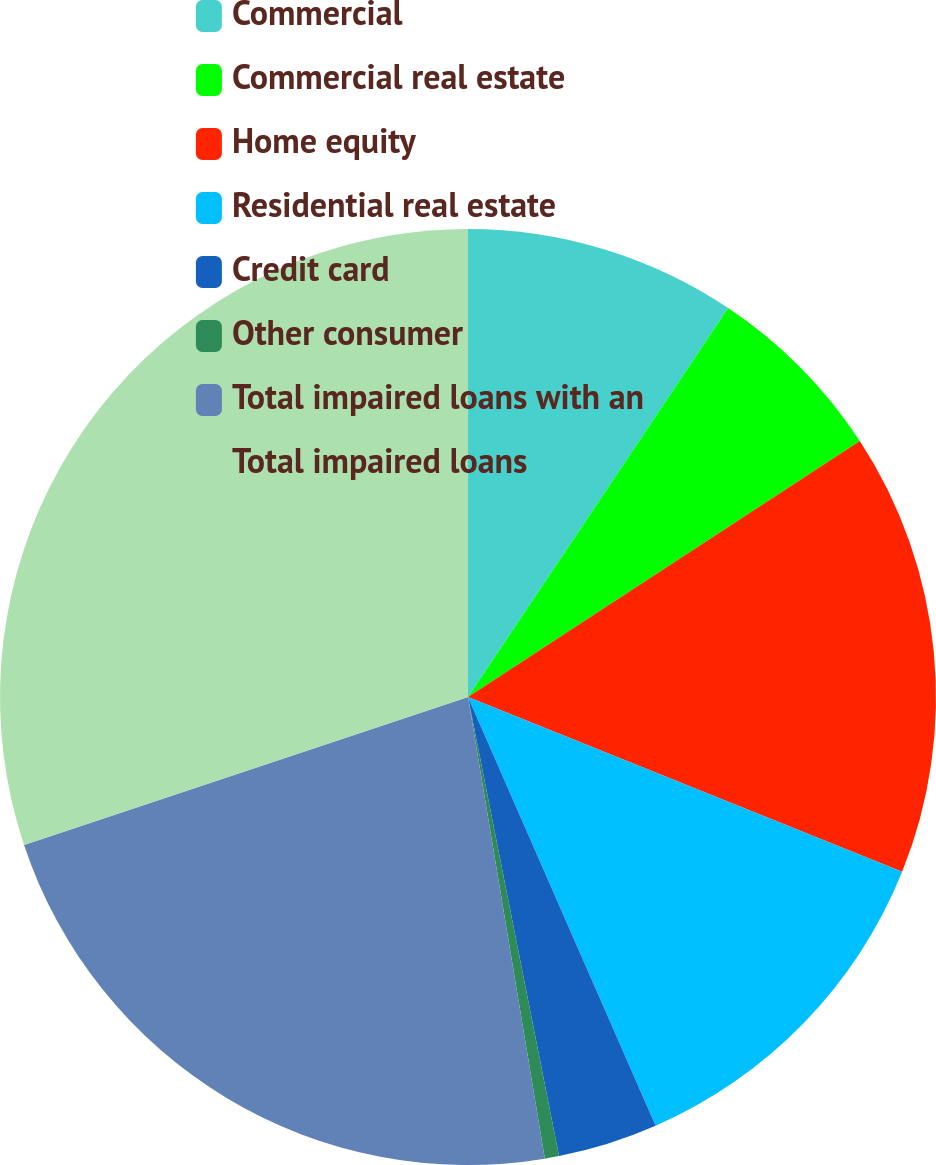<chart> <loc_0><loc_0><loc_500><loc_500><pie_chart><fcel>Commercial<fcel>Commercial real estate<fcel>Home equity<fcel>Residential real estate<fcel>Credit card<fcel>Other consumer<fcel>Total impaired loans with an<fcel>Total impaired loans<nl><fcel>9.38%<fcel>6.41%<fcel>15.3%<fcel>12.34%<fcel>3.45%<fcel>0.49%<fcel>22.5%<fcel>30.12%<nl></chart> 